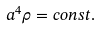Convert formula to latex. <formula><loc_0><loc_0><loc_500><loc_500>a ^ { 4 } \rho = c o n s t .</formula> 